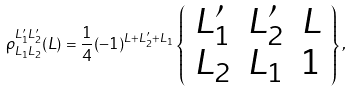<formula> <loc_0><loc_0><loc_500><loc_500>\rho _ { L _ { 1 } L _ { 2 } } ^ { L _ { 1 } ^ { \prime } L _ { 2 } ^ { \prime } } ( L ) = \frac { 1 } { 4 } ( - 1 ) ^ { L + L _ { 2 } ^ { \prime } + L _ { 1 } } \left \{ \begin{array} { c c c } L _ { 1 } ^ { \prime } & L _ { 2 } ^ { \prime } & L \\ L _ { 2 } & L _ { 1 } & 1 \end{array} \right \} ,</formula> 